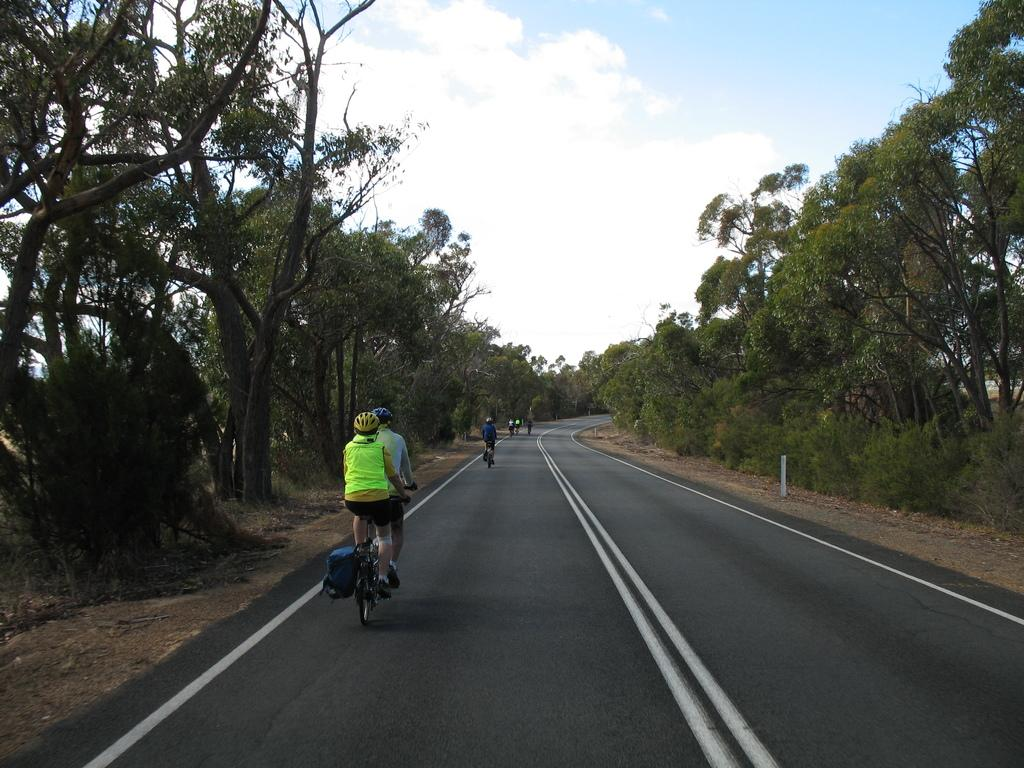What are the people in the image doing? The people in the image are riding bicycles. Where are the people riding their bicycles? The people are riding on a road. What can be seen in the background of the image? There are trees visible in the image. Can you see any monkeys riding the waves with the girls in the image? There are no monkeys, waves, or girls present in the image; it only features people riding bicycles on a road with trees in the background. 